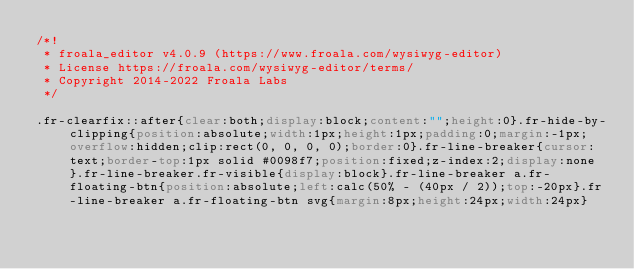<code> <loc_0><loc_0><loc_500><loc_500><_CSS_>/*!
 * froala_editor v4.0.9 (https://www.froala.com/wysiwyg-editor)
 * License https://froala.com/wysiwyg-editor/terms/
 * Copyright 2014-2022 Froala Labs
 */

.fr-clearfix::after{clear:both;display:block;content:"";height:0}.fr-hide-by-clipping{position:absolute;width:1px;height:1px;padding:0;margin:-1px;overflow:hidden;clip:rect(0, 0, 0, 0);border:0}.fr-line-breaker{cursor:text;border-top:1px solid #0098f7;position:fixed;z-index:2;display:none}.fr-line-breaker.fr-visible{display:block}.fr-line-breaker a.fr-floating-btn{position:absolute;left:calc(50% - (40px / 2));top:-20px}.fr-line-breaker a.fr-floating-btn svg{margin:8px;height:24px;width:24px}
</code> 